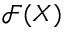Convert formula to latex. <formula><loc_0><loc_0><loc_500><loc_500>{ \mathcal { F } } ( X )</formula> 